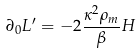<formula> <loc_0><loc_0><loc_500><loc_500>\partial _ { 0 } L ^ { \prime } = - 2 \frac { \kappa ^ { 2 } \rho _ { m } } { \beta } H</formula> 